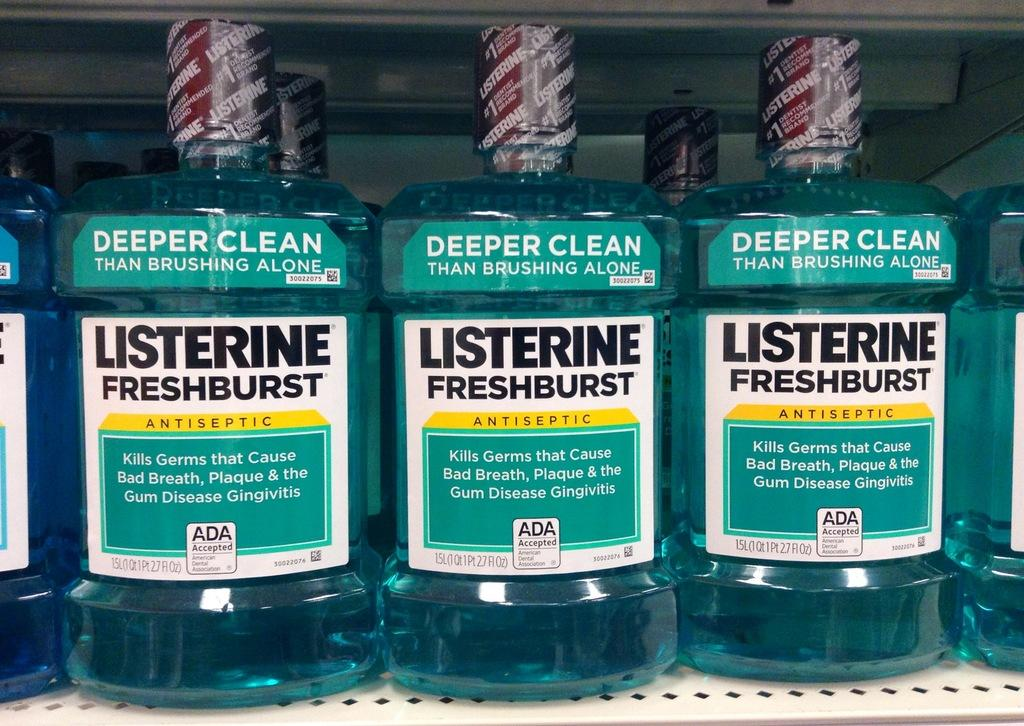What colors are present in the objects visible in the image? The objects in the image are green and blue in color. How many fans are visible in the image? There are no fans present in the image. What type of bed is shown in the image? There is no bed present in the image. 